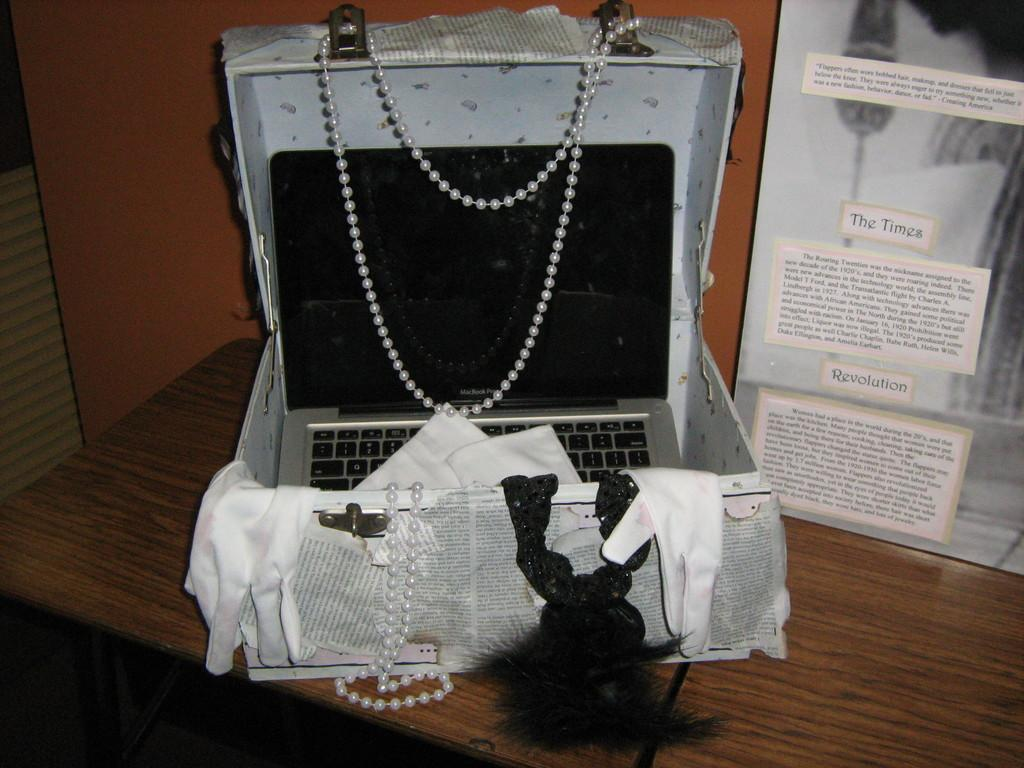What is inside the box that is visible in the image? There is a box with papers, ornaments, and gloves in the image. What is on the table in the image? There is a board on the table in the image. What electronic device is in a box in the image? There is a laptop in a box in the image. What can be seen in the background of the image? There is a wall in the background of the image. What type of pan is being used to catch fish in the image? There is no pan or fishing activity present in the image. 